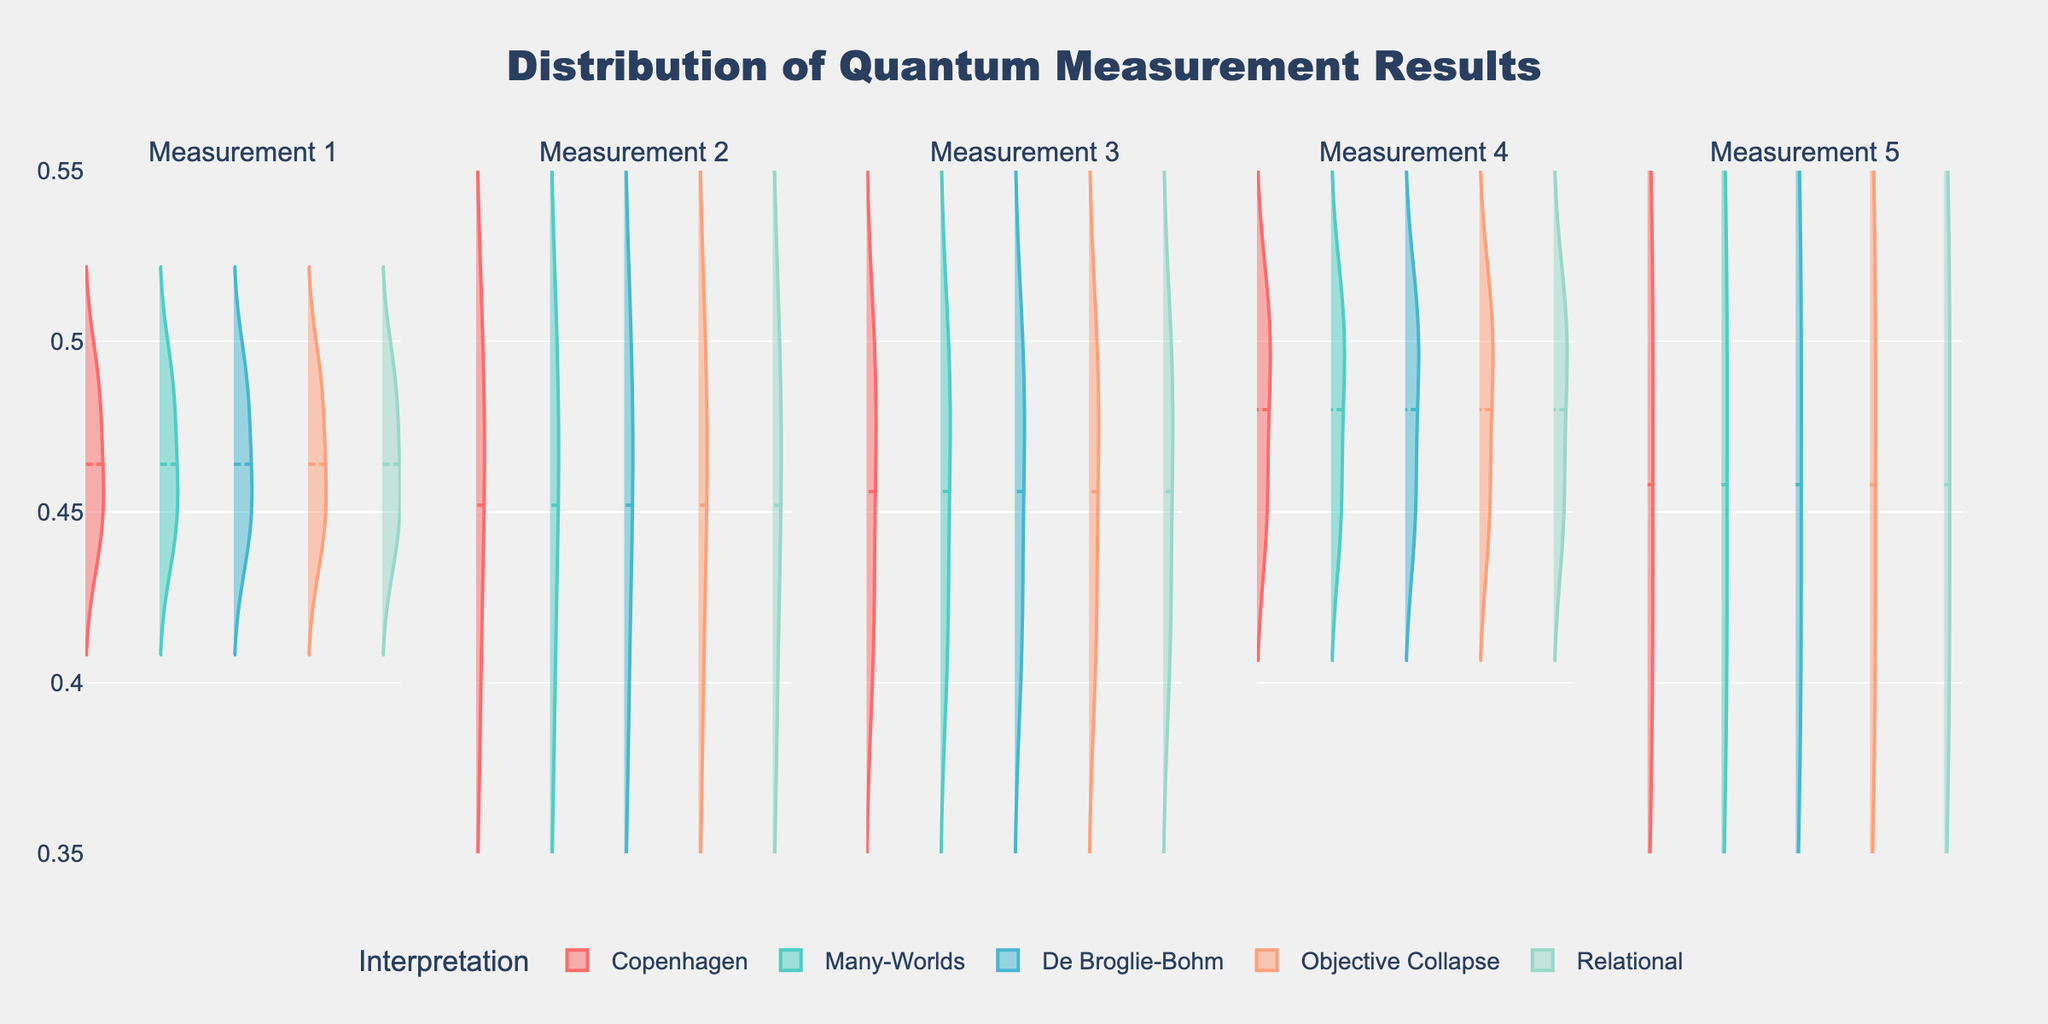What is the title of the figure? The title of the figure is prominently displayed at the top in a larger font size to summarize the content of the plot.
Answer: Distribution of Quantum Measurement Results How many subplots are there in the figure? The figure has multiple violin plots side by side, each representing a measurement. The subplots are distinguishable by the titles above each plot.
Answer: 5 Which interpretation has the highest median value in Measurement 3? By looking at the violin plot for Measurement 3, we can observe the median value indicated by a line in the center of the distribution for each interpretation.
Answer: Relational Which interpretation exhibits a consistent measurement range across all five measurements? Observing the width and spread of each violin plot for all five measurements, we notice the consistency in the range for a particular interpretation.
Answer: Objective Collapse How do the measurements for the Copenhagen and Many-Worlds interpretations compare in Measurement 1? We need to compare the width, position, and shape of the violin plots for Copenhagen and Many-Worlds in Measurement 1 to get insights into their distribution.
Answer: Many-Worlds has a slightly higher central tendency compared to Copenhagen What is the average median value of the Relational interpretation across all measurements? We first find the median value for the Relational interpretation in each measurement and then calculate their average. By summing the medians and dividing by the number of measurements: (0.49 + 0.47 + 0.50 + 0.51 + 0.52)/5 = 2.49/5.
Answer: 0.498 Which measurement shows the widest range of values for the De Broglie-Bohm interpretation? By analyzing the spread of each violin plot for De Broglie-Bohm across all five measurements, we can identify the measurement with the widest distribution
Answer: Measurement 1 Which interpretation has the narrowest distribution in Measurement 4? We examine the width of each violin plot in Measurement 4, and the one with the least spread indicates the narrowest distribution.
Answer: De Broglie-Bohm What is the overall pattern of the measurement results under the Objective Collapse interpretation? The violin plots in the Objective Collapse row across all measurements exhibit consistency; we need to analyze it to infer its overall pattern.
Answer: The values are consistently close to each other across all measurements 